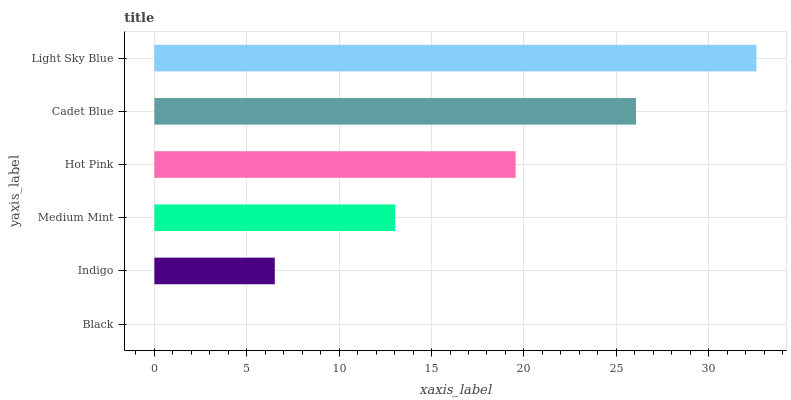Is Black the minimum?
Answer yes or no. Yes. Is Light Sky Blue the maximum?
Answer yes or no. Yes. Is Indigo the minimum?
Answer yes or no. No. Is Indigo the maximum?
Answer yes or no. No. Is Indigo greater than Black?
Answer yes or no. Yes. Is Black less than Indigo?
Answer yes or no. Yes. Is Black greater than Indigo?
Answer yes or no. No. Is Indigo less than Black?
Answer yes or no. No. Is Hot Pink the high median?
Answer yes or no. Yes. Is Medium Mint the low median?
Answer yes or no. Yes. Is Indigo the high median?
Answer yes or no. No. Is Cadet Blue the low median?
Answer yes or no. No. 